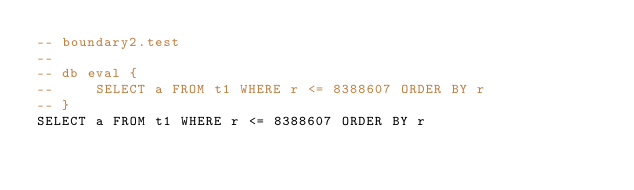<code> <loc_0><loc_0><loc_500><loc_500><_SQL_>-- boundary2.test
-- 
-- db eval {
--     SELECT a FROM t1 WHERE r <= 8388607 ORDER BY r
-- }
SELECT a FROM t1 WHERE r <= 8388607 ORDER BY r</code> 